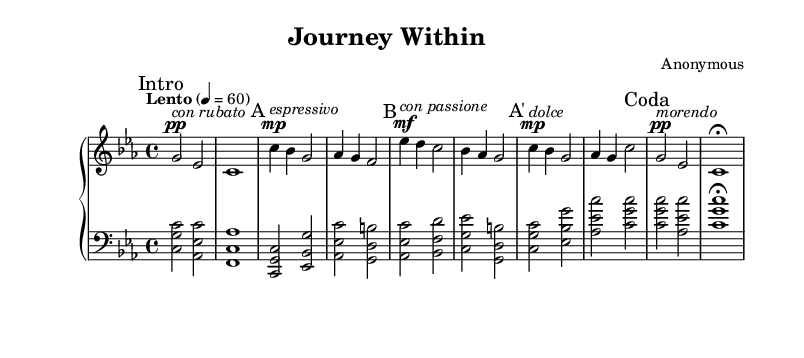What is the key signature of this music? The key signature is C minor, which has three flats (B♭, E♭, A♭). This can be determined by looking at the key signature indicated at the beginning of the sheet music.
Answer: C minor What is the time signature of this composition? The time signature is 4/4, indicated at the beginning of the score. This means there are four beats in each measure, and the quarter note receives one beat.
Answer: 4/4 What is the tempo marking for this piece? The tempo marking is "Lento," which indicates a slow tempo. It is specified that the quarter note equals 60 beats per minute, providing guidance on the speed of performance.
Answer: Lento How many main sections are there in the piece? The piece is structured with three main sections: A, B, and A' (with a Coda). The sections are marked clearly within the score, showcasing the overall form.
Answer: Three Which dynamic marking appears at the beginning of the A section? The dynamic marking at the beginning of the A section is "mp," which stands for mezzo-piano, indicating a moderately soft volume. This is specified right before the musical phrase begins.
Answer: mp What does "con rubato" imply in the music? "Con rubato" implies that the tempo may be flexible, allowing the performer to slightly push and pull the timing for expressive purposes. This is suggested by the directive placed above the corresponding measure in the score.
Answer: Flexible timing What does the term "morendo" indicate at the end of the composition? The term "morendo" means to fade away or gradually get softer. This instruction is found in the Coda section, signaling the performer to diminish the sound leading to the final note.
Answer: Fade away 